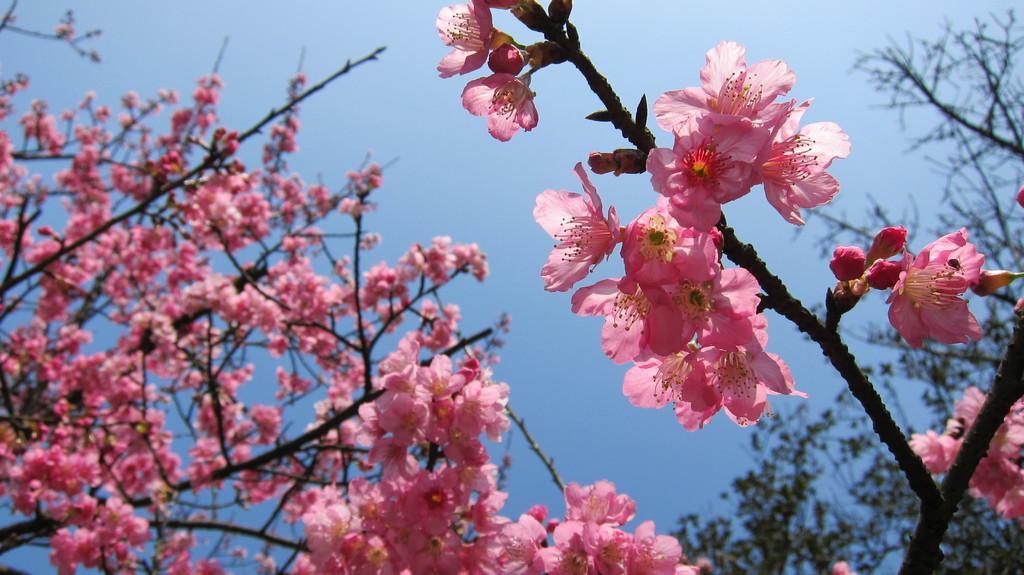Please provide a concise description of this image. In this image we can see branches with flowers and buds. In the background there are branches of trees. Also there is sky. 